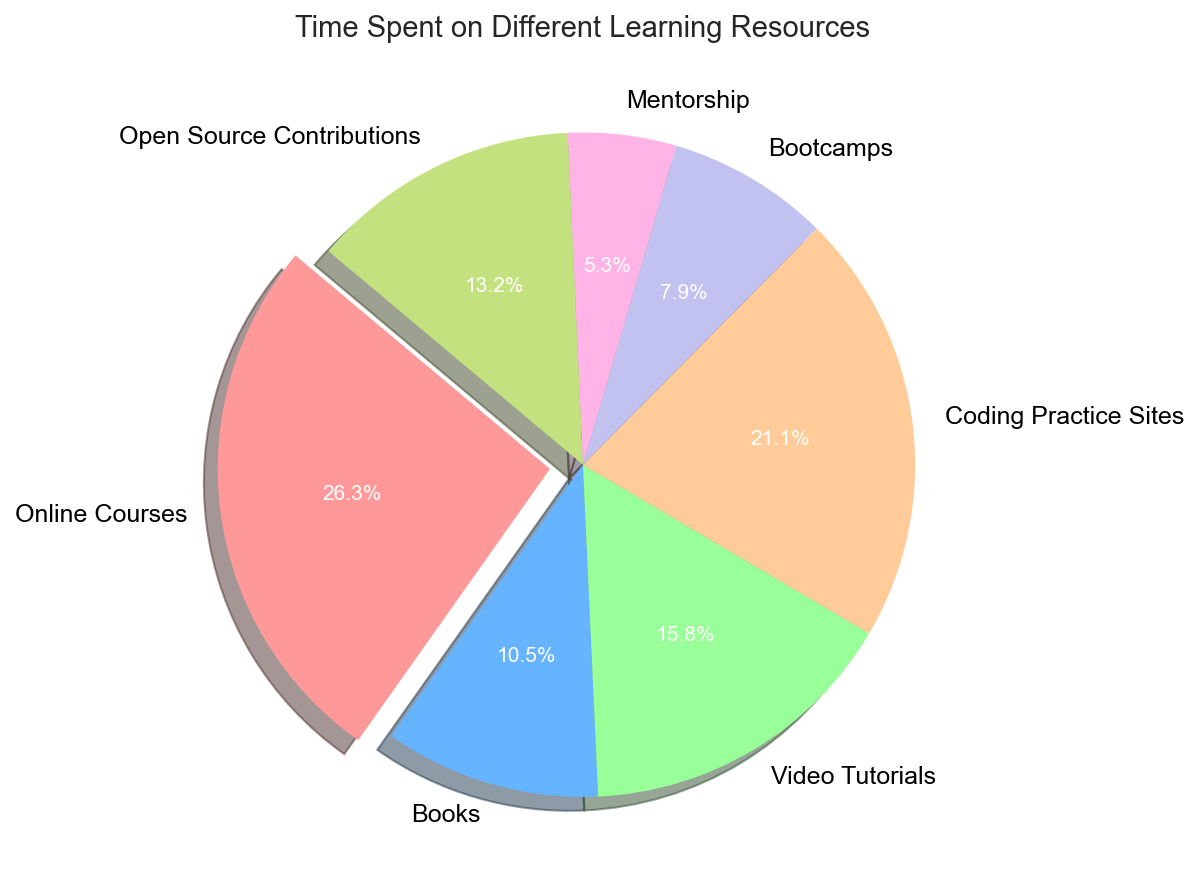What is the largest segment in the pie chart? To determine the largest segment, we look for the slice that stands out due to its size or exploded portion. The slice representing "Online Courses" is the largest and has been exploded slightly.
Answer: Online Courses Which two resources have the smallest time spent? Identify the two smallest slices in the pie chart by comparing their sizes visually. The slices representing "Mentorship" (10 hours) and "Bootcamps" (15 hours) are the smallest.
Answer: Mentorship and Bootcamps How is the time spent on Video Tutorials compared to Open Source Contributions? We need to compare the sizes of the slices for "Video Tutorials" and "Open Source Contributions." Video Tutorials have a larger slice (30 hours) compared to Open Source Contributions (25 hours).
Answer: Video Tutorials have more time spent than Open Source Contributions What percentage of time is spent on Coding Practice Sites? Locate the slice for "Coding Practice Sites" and refer to its percentage label. The label shows that 22.5% of the time is spent on Coding Practice Sites.
Answer: 22.5% How much more time is spent on Online Courses than on Books? Find the time spent on Online Courses (50 hours) and Books (20 hours), then calculate the difference (50 - 20).
Answer: 30 hours What is the combined percentage of time spent on Mentorship and Bootcamps? Find the percentage labels for Mentorship and Bootcamps, which are 5.6% and 8.4% respectively, and then sum them up (5.6% + 8.4%).
Answer: 14% What is the average time spent across all the resources? Sum all the time spent values (50 + 20 + 30 + 40 + 15 + 10 + 25 = 190), then divide by the number of resources (7).
Answer: Approximately 27.1 hours Is the time spent on Coding Practice Sites greater than the total time spent on Mentorship and Bootcamps combined? Sum the time for Mentorship (10 hours) and Bootcamps (15 hours) to get 25 hours, then compare this with the time spent on Coding Practice Sites (40 hours).
Answer: Yes What slice is the color green representing? By identifying the color green in the visual, we find it represents the slice for "Coding Practice Sites."
Answer: Coding Practice Sites What percent more time is spent on Online Courses compared to Video Tutorials? Calculate the percentage of time for Online Courses (50 hours) and Video Tutorials (30 hours). The difference is 20 hours. To find the percentage difference relative to Video Tutorials: (20/30) * 100% = 66.7%.
Answer: 66.7% 